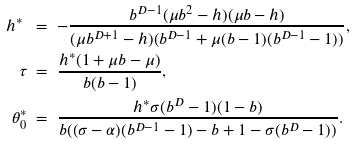Convert formula to latex. <formula><loc_0><loc_0><loc_500><loc_500>h ^ { * } \ & = \ - \frac { b ^ { D - 1 } ( \mu b ^ { 2 } - h ) ( \mu b - h ) } { ( \mu b ^ { D + 1 } - h ) ( b ^ { D - 1 } + \mu ( b - 1 ) ( b ^ { D - 1 } - 1 ) ) } , \\ \tau \ & = \ \frac { h ^ { * } ( 1 + \mu b - \mu ) } { b ( b - 1 ) } , \\ \theta ^ { * } _ { 0 } \ & = \ \frac { h ^ { * } \sigma ( b ^ { D } - 1 ) ( 1 - b ) } { b ( ( \sigma - \alpha ) ( b ^ { D - 1 } - 1 ) - b + 1 - \sigma ( b ^ { D } - 1 ) ) } .</formula> 